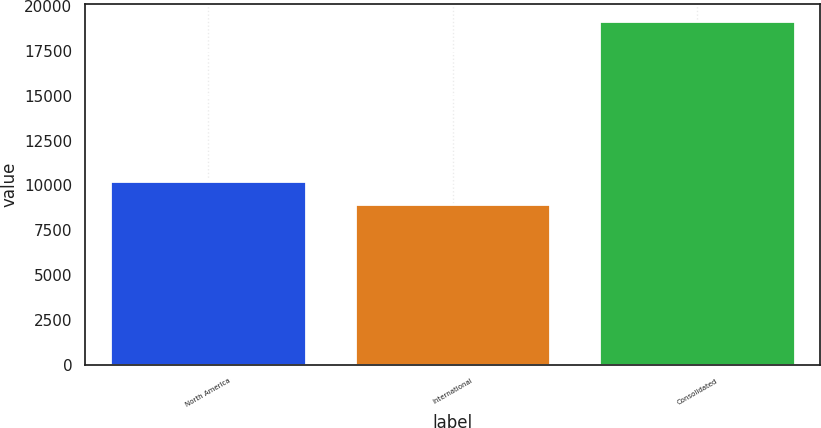Convert chart to OTSL. <chart><loc_0><loc_0><loc_500><loc_500><bar_chart><fcel>North America<fcel>International<fcel>Consolidated<nl><fcel>10228<fcel>8938<fcel>19166<nl></chart> 